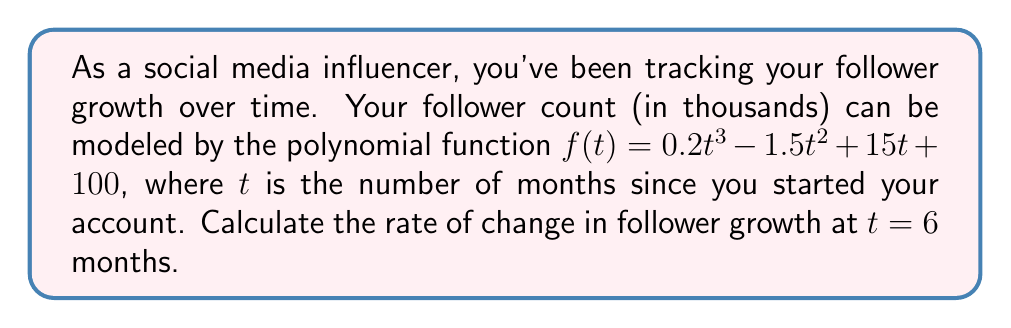Solve this math problem. To solve this problem, we need to find the derivative of the given polynomial function and then evaluate it at $t = 6$. Here's the step-by-step process:

1) The given function is:
   $f(t) = 0.2t^3 - 1.5t^2 + 15t + 100$

2) To find the rate of change, we need to calculate $f'(t)$. Using the power rule of differentiation:

   $f'(t) = 0.2 \cdot 3t^2 - 1.5 \cdot 2t + 15$
   
   $f'(t) = 0.6t^2 - 3t + 15$

3) Now that we have the derivative, we can calculate the rate of change at $t = 6$ by evaluating $f'(6)$:

   $f'(6) = 0.6(6^2) - 3(6) + 15$
   
   $f'(6) = 0.6(36) - 18 + 15$
   
   $f'(6) = 21.6 - 18 + 15$
   
   $f'(6) = 18.6$

4) The rate of change is measured in thousands of followers per month, so we need to interpret this result accordingly.
Answer: The rate of change in follower growth at 6 months is 18,600 followers per month. 